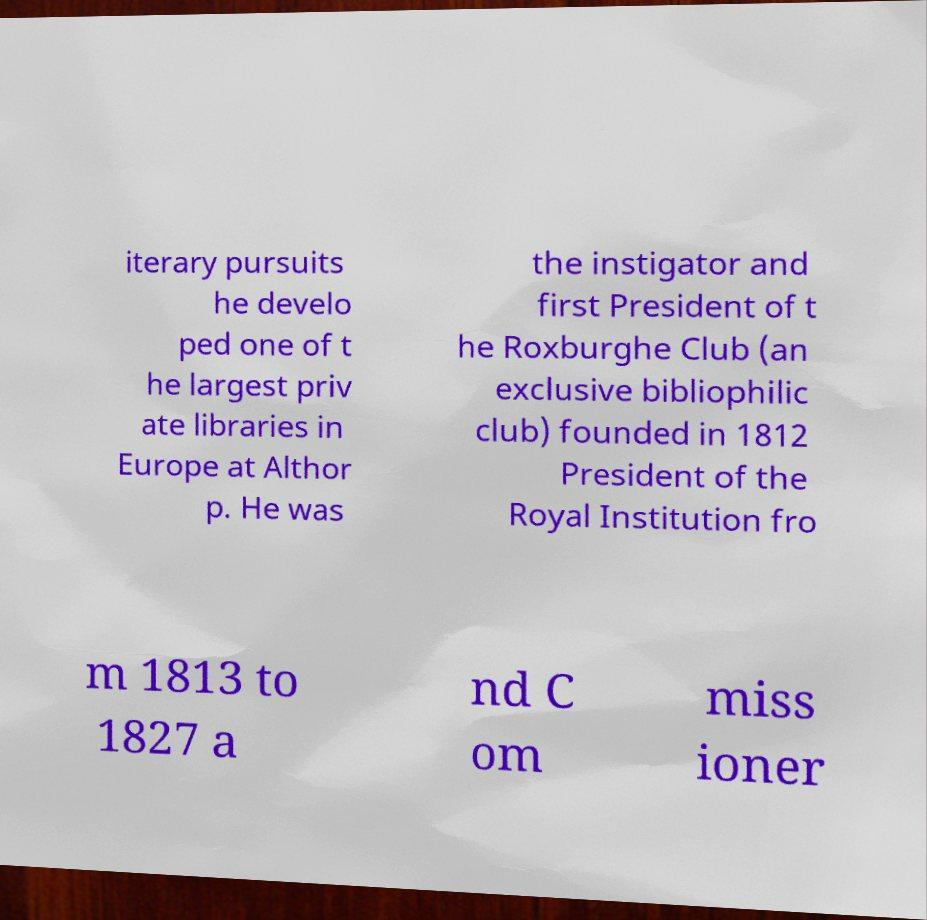There's text embedded in this image that I need extracted. Can you transcribe it verbatim? iterary pursuits he develo ped one of t he largest priv ate libraries in Europe at Althor p. He was the instigator and first President of t he Roxburghe Club (an exclusive bibliophilic club) founded in 1812 President of the Royal Institution fro m 1813 to 1827 a nd C om miss ioner 